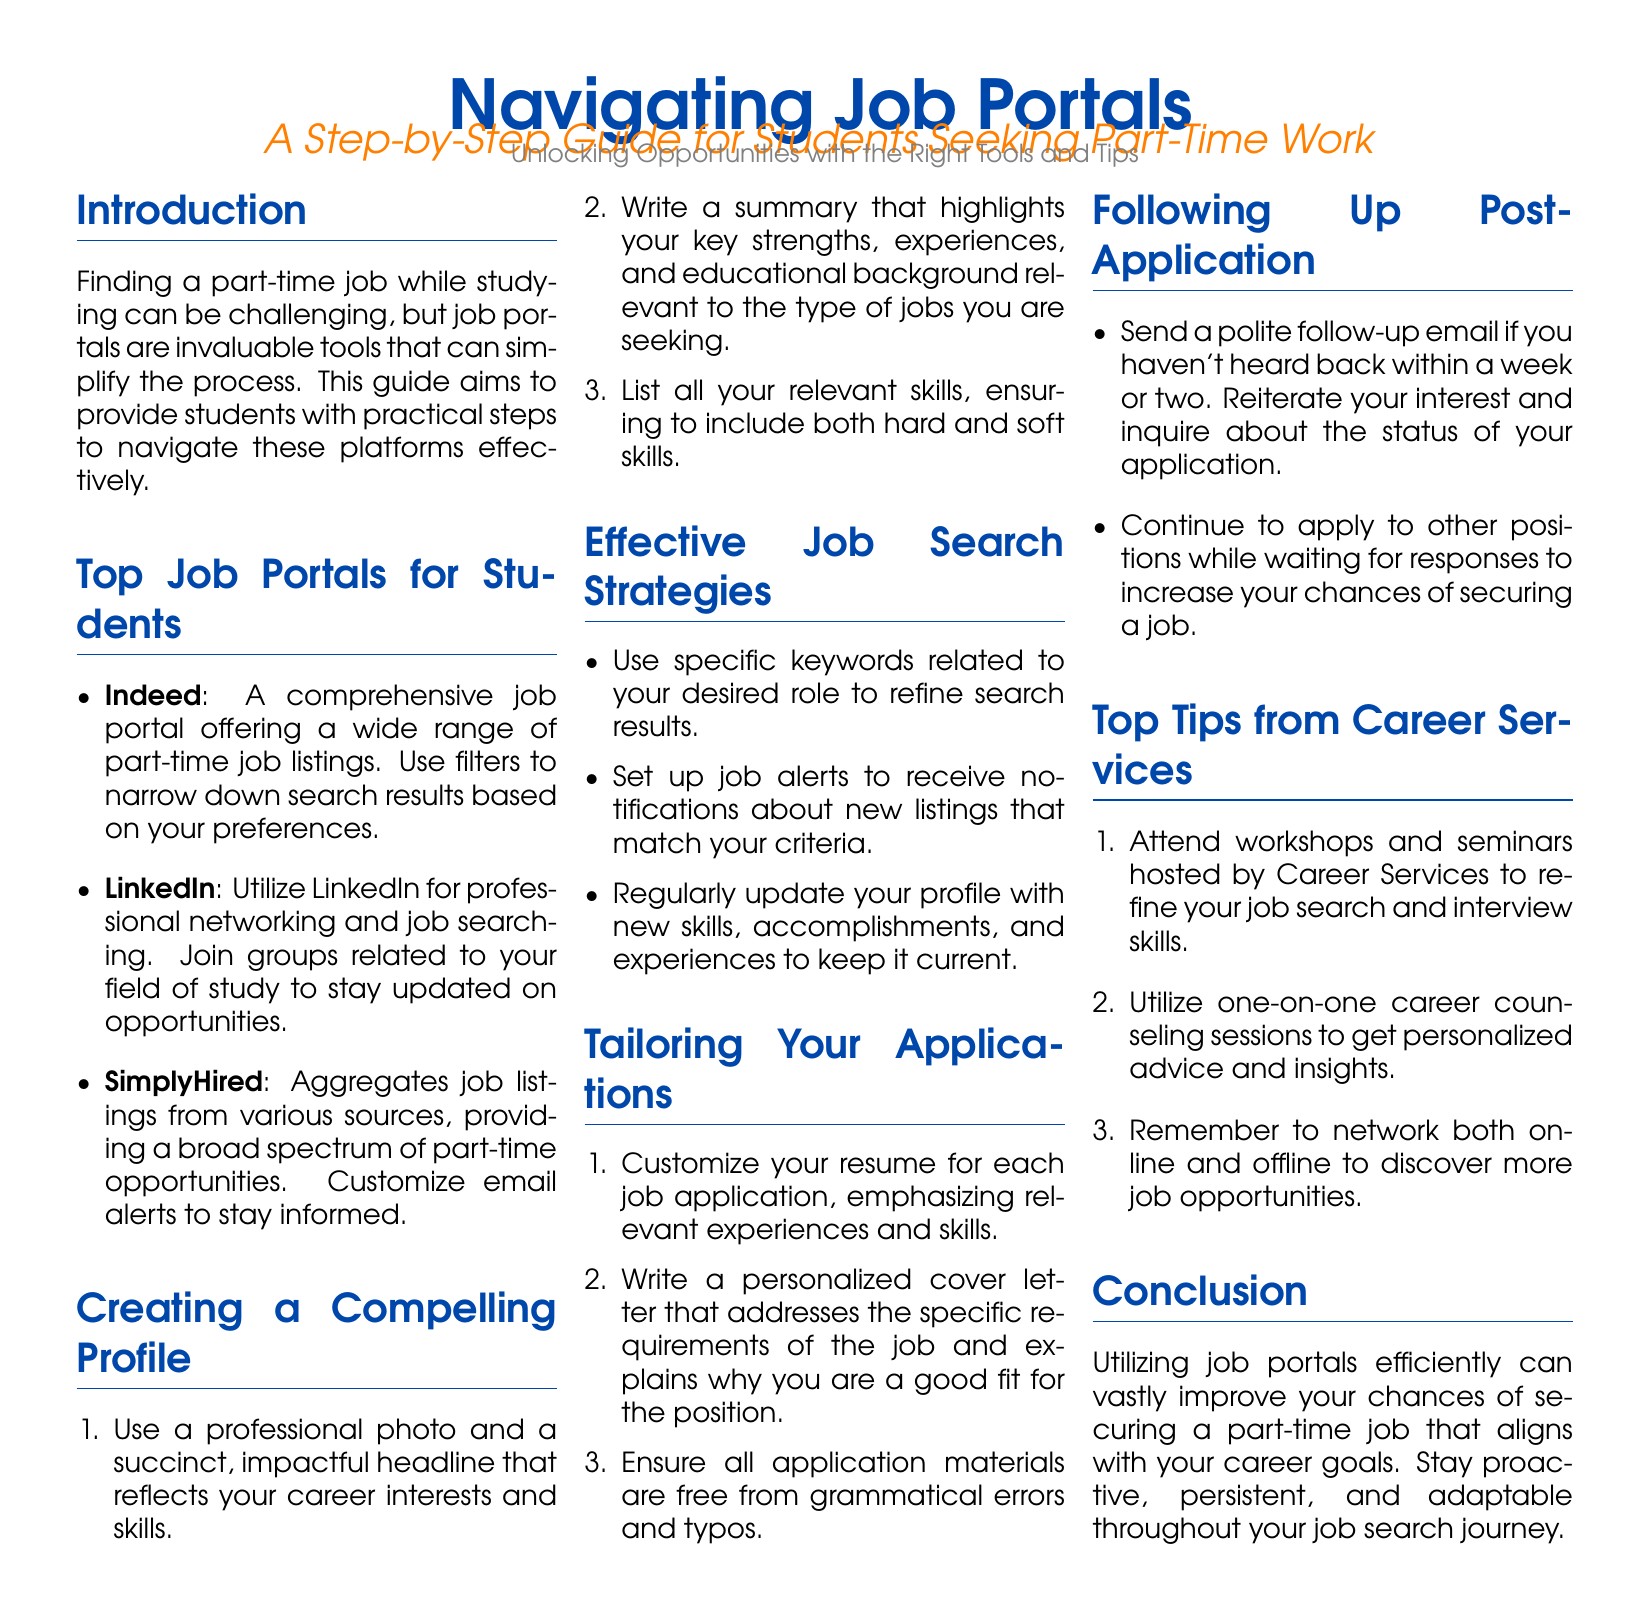What are the top three job portals mentioned? The document lists three job portals under "Top Job Portals for Students", which are Indeed, LinkedIn, and SimplyHired.
Answer: Indeed, LinkedIn, SimplyHired How many tips are provided in the "Top Tips from Career Services" section? The section "Top Tips from Career Services" contains a list of three tips.
Answer: 3 What should you include in your profile summary? The summary should highlight key strengths, experiences, and educational background relevant to the type of jobs being sought.
Answer: Key strengths, experiences, educational background What is the purpose of setting up job alerts? Setting up job alerts helps in receiving notifications about new listings that match specific criteria.
Answer: Receive notifications How long should you wait before sending a follow-up email post-application? The document suggests sending a follow-up email if you haven't heard back within a week or two.
Answer: A week or two What type of photo should you use in your profile? The document recommends using a professional photo in your profile.
Answer: Professional photo What is a key strategy for tailoring applications? One key strategy is to customize your resume for each job application to emphasize relevant experiences and skills.
Answer: Customize your resume How does attending workshops help students? Attending workshops helps refine job search and interview skills according to the document.
Answer: Refine job search and interview skills 